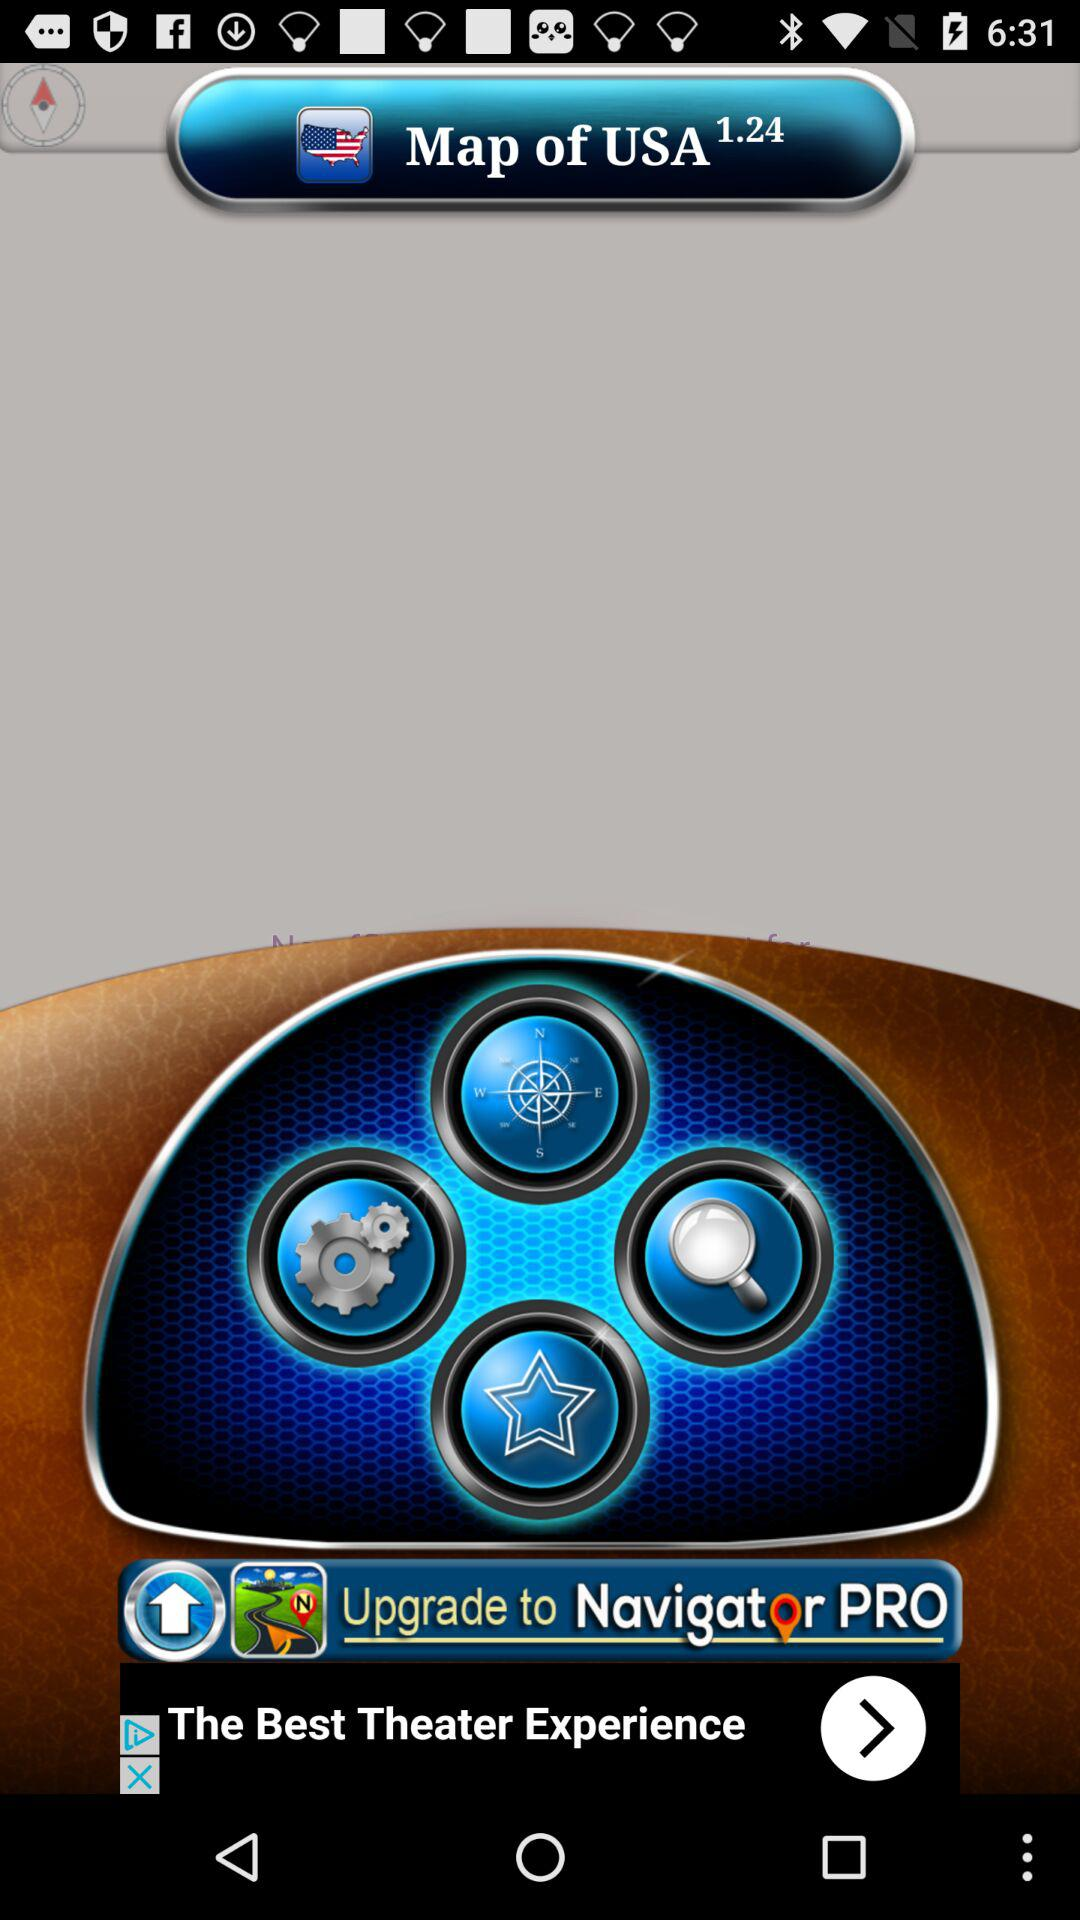Which country's map is selected?
When the provided information is insufficient, respond with <no answer>. <no answer> 